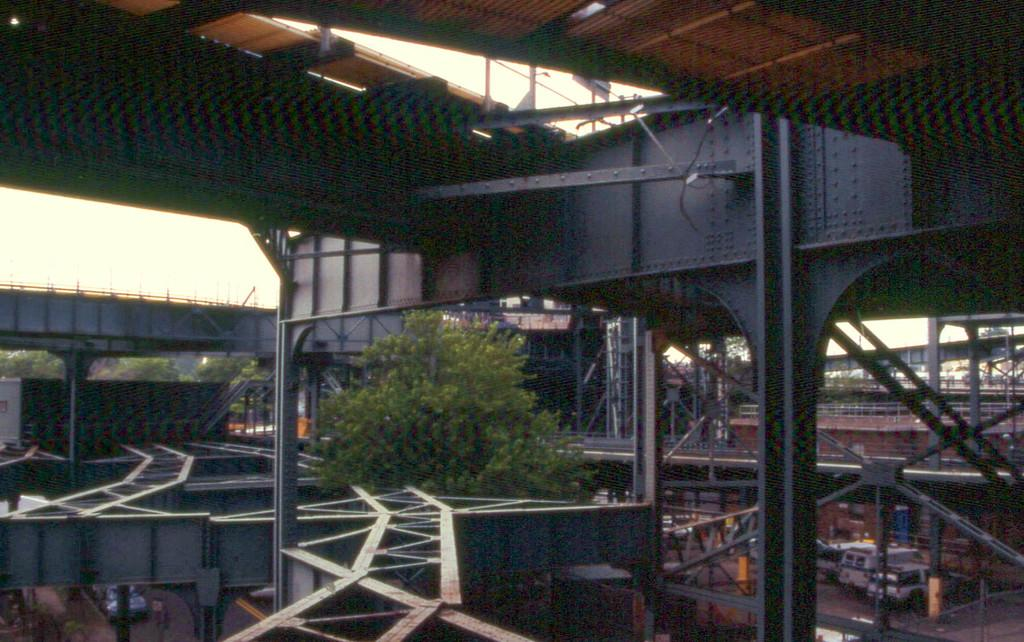What type of bridge is shown in the image? There is an iron bridge in the image. What material is the bridge made of? The bridge is built with iron. What can be seen in the background of the image? There are trees visible in the image. What type of vehicles can be seen in the image? There are parked cars in the image. How many frogs are sitting on the oven in the image? There are no frogs or ovens present in the image. What type of organization is responsible for maintaining the bridge in the image? The provided facts do not mention any organization responsible for maintaining the bridge, so we cannot answer this question. 